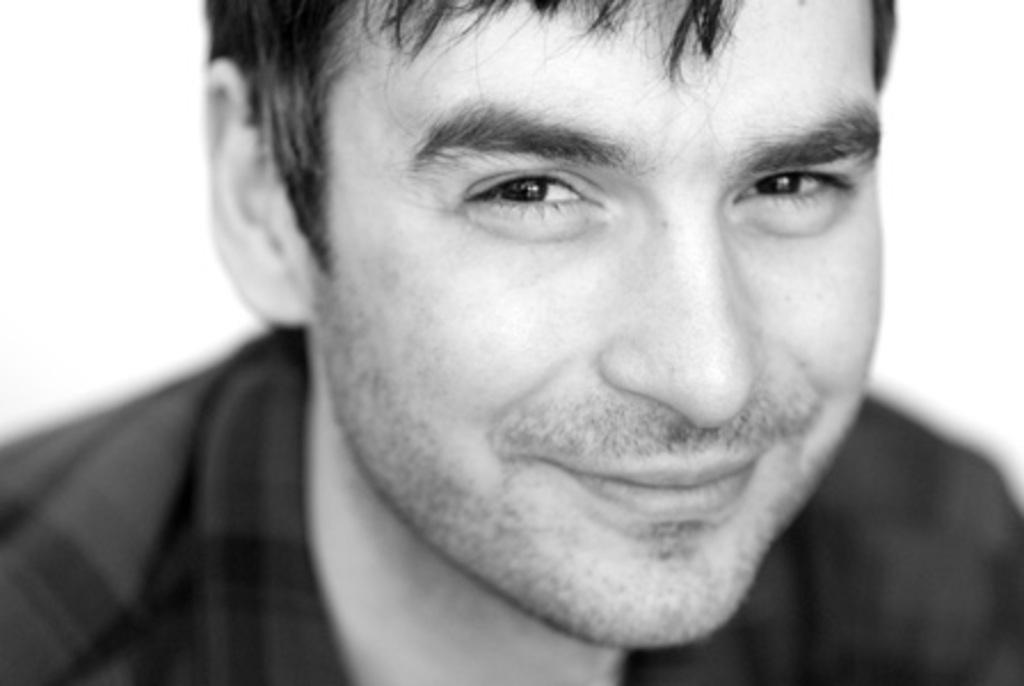What is the color scheme of the image? The image is black and white. Who is present in the image? There is a man in the image. What is the man's facial expression? The man has a smiling face. What color is the background of the image? The background of the image is white. How much does the weight of the cord affect the man's posture in the image? There is no cord present in the image, so its weight cannot affect the man's posture. 